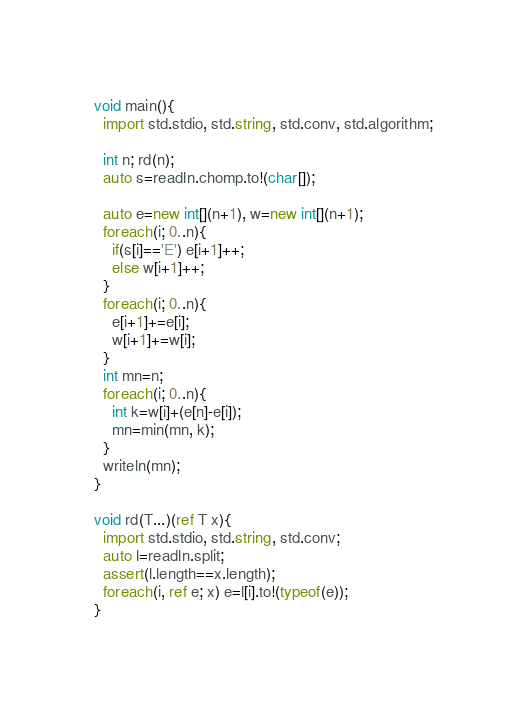<code> <loc_0><loc_0><loc_500><loc_500><_D_>void main(){
  import std.stdio, std.string, std.conv, std.algorithm;

  int n; rd(n);
  auto s=readln.chomp.to!(char[]);

  auto e=new int[](n+1), w=new int[](n+1);
  foreach(i; 0..n){
    if(s[i]=='E') e[i+1]++;
    else w[i+1]++;
  }
  foreach(i; 0..n){
    e[i+1]+=e[i];
    w[i+1]+=w[i];
  }
  int mn=n;
  foreach(i; 0..n){
    int k=w[i]+(e[n]-e[i]);
    mn=min(mn, k);
  }
  writeln(mn);
}

void rd(T...)(ref T x){
  import std.stdio, std.string, std.conv;
  auto l=readln.split;
  assert(l.length==x.length);
  foreach(i, ref e; x) e=l[i].to!(typeof(e));
}
</code> 